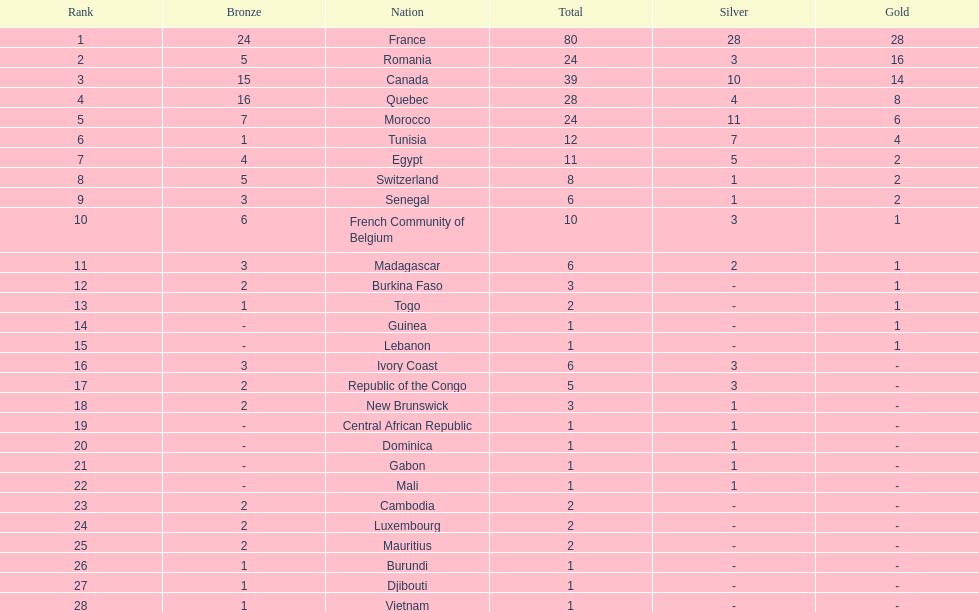What is the difference between france's and egypt's silver medals? 23. 